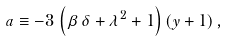Convert formula to latex. <formula><loc_0><loc_0><loc_500><loc_500>a \equiv - 3 \, \left ( \beta \, \delta + { \lambda } ^ { 2 } + 1 \right ) \left ( y + 1 \right ) ,</formula> 